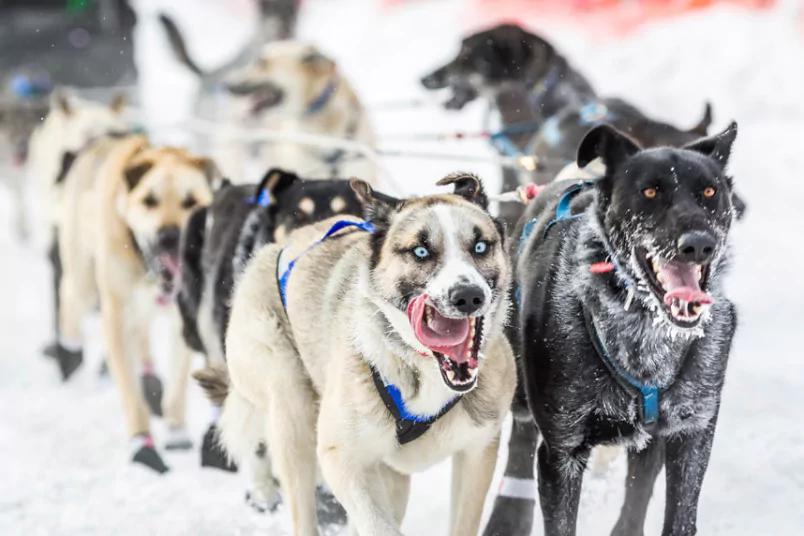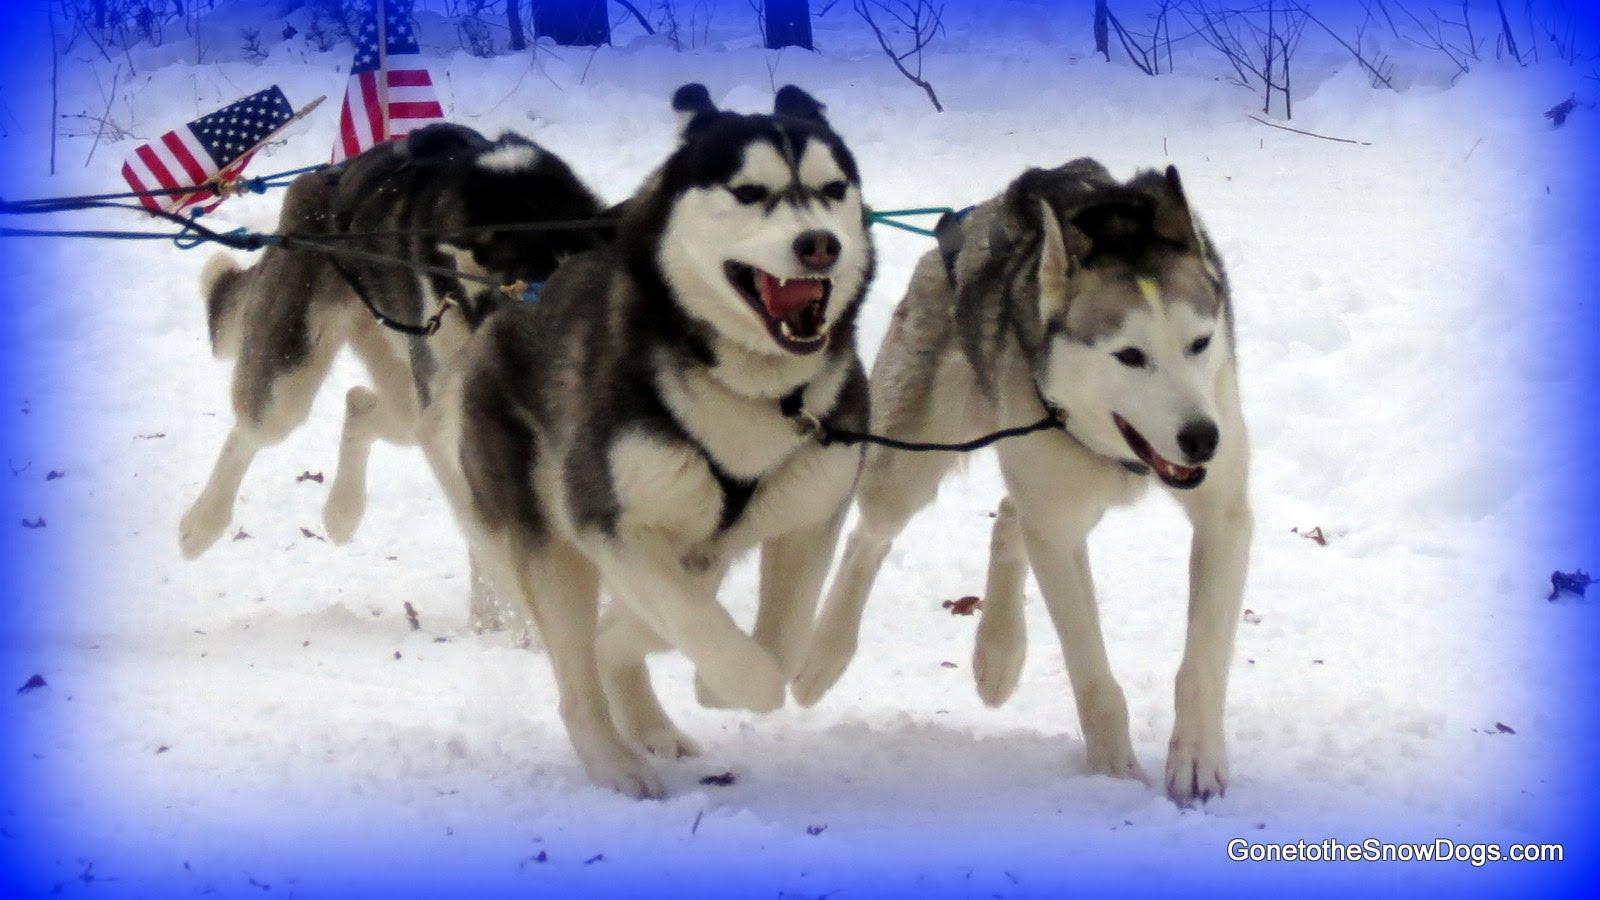The first image is the image on the left, the second image is the image on the right. Examine the images to the left and right. Is the description "There are dogs wearing colored socks in at least one image." accurate? Answer yes or no. No. The first image is the image on the left, the second image is the image on the right. Evaluate the accuracy of this statement regarding the images: "There are dogs wearing colorful paw coverups.". Is it true? Answer yes or no. No. 